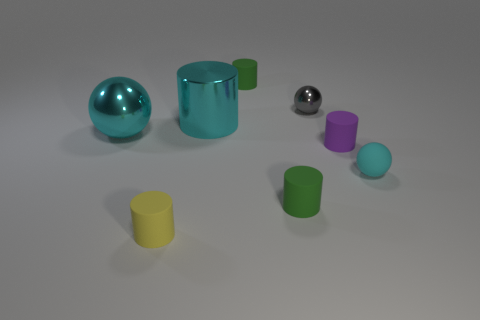Subtract all big cylinders. How many cylinders are left? 4 Subtract all cyan cylinders. How many cylinders are left? 4 Subtract all blue cylinders. Subtract all blue balls. How many cylinders are left? 5 Add 1 big blue matte spheres. How many objects exist? 9 Subtract all cylinders. How many objects are left? 3 Add 5 yellow matte cylinders. How many yellow matte cylinders exist? 6 Subtract 0 cyan blocks. How many objects are left? 8 Subtract all small yellow things. Subtract all cyan objects. How many objects are left? 4 Add 4 large spheres. How many large spheres are left? 5 